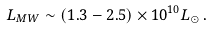<formula> <loc_0><loc_0><loc_500><loc_500>L _ { M W } \sim ( 1 . 3 - 2 . 5 ) \times 1 0 ^ { 1 0 } L _ { \odot } \, .</formula> 